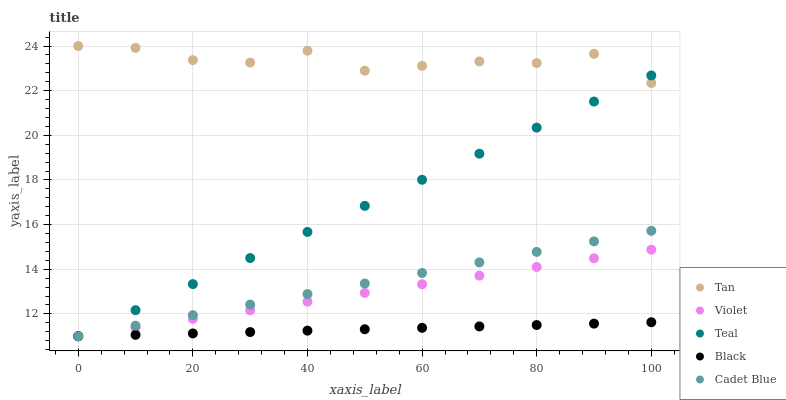Does Black have the minimum area under the curve?
Answer yes or no. Yes. Does Tan have the maximum area under the curve?
Answer yes or no. Yes. Does Cadet Blue have the minimum area under the curve?
Answer yes or no. No. Does Cadet Blue have the maximum area under the curve?
Answer yes or no. No. Is Violet the smoothest?
Answer yes or no. Yes. Is Tan the roughest?
Answer yes or no. Yes. Is Cadet Blue the smoothest?
Answer yes or no. No. Is Cadet Blue the roughest?
Answer yes or no. No. Does Cadet Blue have the lowest value?
Answer yes or no. Yes. Does Tan have the highest value?
Answer yes or no. Yes. Does Cadet Blue have the highest value?
Answer yes or no. No. Is Cadet Blue less than Tan?
Answer yes or no. Yes. Is Tan greater than Cadet Blue?
Answer yes or no. Yes. Does Cadet Blue intersect Teal?
Answer yes or no. Yes. Is Cadet Blue less than Teal?
Answer yes or no. No. Is Cadet Blue greater than Teal?
Answer yes or no. No. Does Cadet Blue intersect Tan?
Answer yes or no. No. 